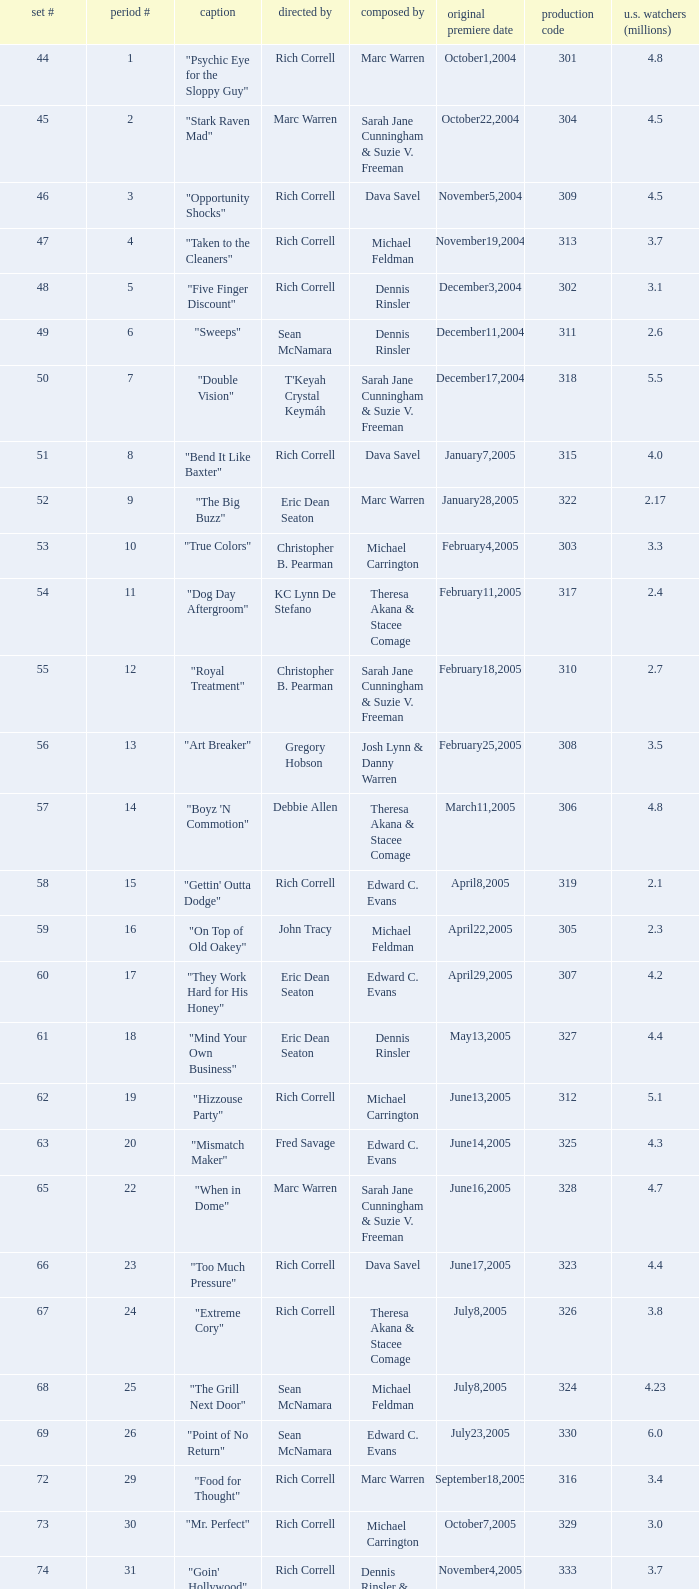Can you give me this table as a dict? {'header': ['set #', 'period #', 'caption', 'directed by', 'composed by', 'original premiere date', 'production code', 'u.s. watchers (millions)'], 'rows': [['44', '1', '"Psychic Eye for the Sloppy Guy"', 'Rich Correll', 'Marc Warren', 'October1,2004', '301', '4.8'], ['45', '2', '"Stark Raven Mad"', 'Marc Warren', 'Sarah Jane Cunningham & Suzie V. Freeman', 'October22,2004', '304', '4.5'], ['46', '3', '"Opportunity Shocks"', 'Rich Correll', 'Dava Savel', 'November5,2004', '309', '4.5'], ['47', '4', '"Taken to the Cleaners"', 'Rich Correll', 'Michael Feldman', 'November19,2004', '313', '3.7'], ['48', '5', '"Five Finger Discount"', 'Rich Correll', 'Dennis Rinsler', 'December3,2004', '302', '3.1'], ['49', '6', '"Sweeps"', 'Sean McNamara', 'Dennis Rinsler', 'December11,2004', '311', '2.6'], ['50', '7', '"Double Vision"', "T'Keyah Crystal Keymáh", 'Sarah Jane Cunningham & Suzie V. Freeman', 'December17,2004', '318', '5.5'], ['51', '8', '"Bend It Like Baxter"', 'Rich Correll', 'Dava Savel', 'January7,2005', '315', '4.0'], ['52', '9', '"The Big Buzz"', 'Eric Dean Seaton', 'Marc Warren', 'January28,2005', '322', '2.17'], ['53', '10', '"True Colors"', 'Christopher B. Pearman', 'Michael Carrington', 'February4,2005', '303', '3.3'], ['54', '11', '"Dog Day Aftergroom"', 'KC Lynn De Stefano', 'Theresa Akana & Stacee Comage', 'February11,2005', '317', '2.4'], ['55', '12', '"Royal Treatment"', 'Christopher B. Pearman', 'Sarah Jane Cunningham & Suzie V. Freeman', 'February18,2005', '310', '2.7'], ['56', '13', '"Art Breaker"', 'Gregory Hobson', 'Josh Lynn & Danny Warren', 'February25,2005', '308', '3.5'], ['57', '14', '"Boyz \'N Commotion"', 'Debbie Allen', 'Theresa Akana & Stacee Comage', 'March11,2005', '306', '4.8'], ['58', '15', '"Gettin\' Outta Dodge"', 'Rich Correll', 'Edward C. Evans', 'April8,2005', '319', '2.1'], ['59', '16', '"On Top of Old Oakey"', 'John Tracy', 'Michael Feldman', 'April22,2005', '305', '2.3'], ['60', '17', '"They Work Hard for His Honey"', 'Eric Dean Seaton', 'Edward C. Evans', 'April29,2005', '307', '4.2'], ['61', '18', '"Mind Your Own Business"', 'Eric Dean Seaton', 'Dennis Rinsler', 'May13,2005', '327', '4.4'], ['62', '19', '"Hizzouse Party"', 'Rich Correll', 'Michael Carrington', 'June13,2005', '312', '5.1'], ['63', '20', '"Mismatch Maker"', 'Fred Savage', 'Edward C. Evans', 'June14,2005', '325', '4.3'], ['65', '22', '"When in Dome"', 'Marc Warren', 'Sarah Jane Cunningham & Suzie V. Freeman', 'June16,2005', '328', '4.7'], ['66', '23', '"Too Much Pressure"', 'Rich Correll', 'Dava Savel', 'June17,2005', '323', '4.4'], ['67', '24', '"Extreme Cory"', 'Rich Correll', 'Theresa Akana & Stacee Comage', 'July8,2005', '326', '3.8'], ['68', '25', '"The Grill Next Door"', 'Sean McNamara', 'Michael Feldman', 'July8,2005', '324', '4.23'], ['69', '26', '"Point of No Return"', 'Sean McNamara', 'Edward C. Evans', 'July23,2005', '330', '6.0'], ['72', '29', '"Food for Thought"', 'Rich Correll', 'Marc Warren', 'September18,2005', '316', '3.4'], ['73', '30', '"Mr. Perfect"', 'Rich Correll', 'Michael Carrington', 'October7,2005', '329', '3.0'], ['74', '31', '"Goin\' Hollywood"', 'Rich Correll', 'Dennis Rinsler & Marc Warren', 'November4,2005', '333', '3.7'], ['75', '32', '"Save the Last Dance"', 'Sean McNamara', 'Marc Warren', 'November25,2005', '334', '3.3'], ['76', '33', '"Cake Fear"', 'Rondell Sheridan', 'Theresa Akana & Stacee Comage', 'December16,2005', '332', '3.6'], ['77', '34', '"Vision Impossible"', 'Marc Warren', 'David Brookwell & Sean McNamara', 'January6,2006', '335', '4.7']]} What was the production code of the episode directed by Rondell Sheridan?  332.0. 